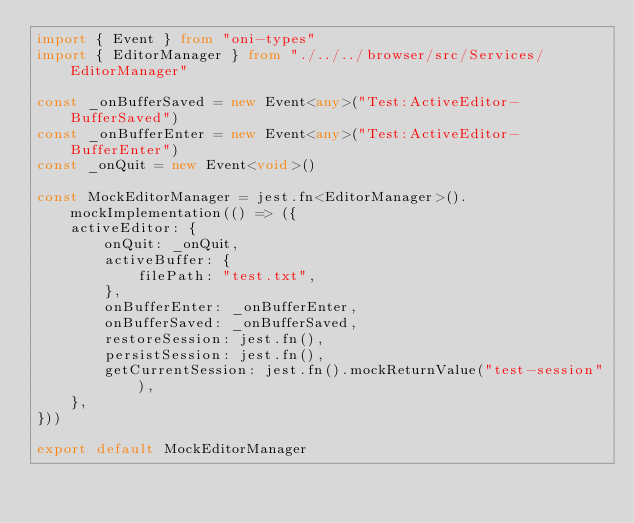Convert code to text. <code><loc_0><loc_0><loc_500><loc_500><_TypeScript_>import { Event } from "oni-types"
import { EditorManager } from "./../../browser/src/Services/EditorManager"

const _onBufferSaved = new Event<any>("Test:ActiveEditor-BufferSaved")
const _onBufferEnter = new Event<any>("Test:ActiveEditor-BufferEnter")
const _onQuit = new Event<void>()

const MockEditorManager = jest.fn<EditorManager>().mockImplementation(() => ({
    activeEditor: {
        onQuit: _onQuit,
        activeBuffer: {
            filePath: "test.txt",
        },
        onBufferEnter: _onBufferEnter,
        onBufferSaved: _onBufferSaved,
        restoreSession: jest.fn(),
        persistSession: jest.fn(),
        getCurrentSession: jest.fn().mockReturnValue("test-session"),
    },
}))

export default MockEditorManager
</code> 